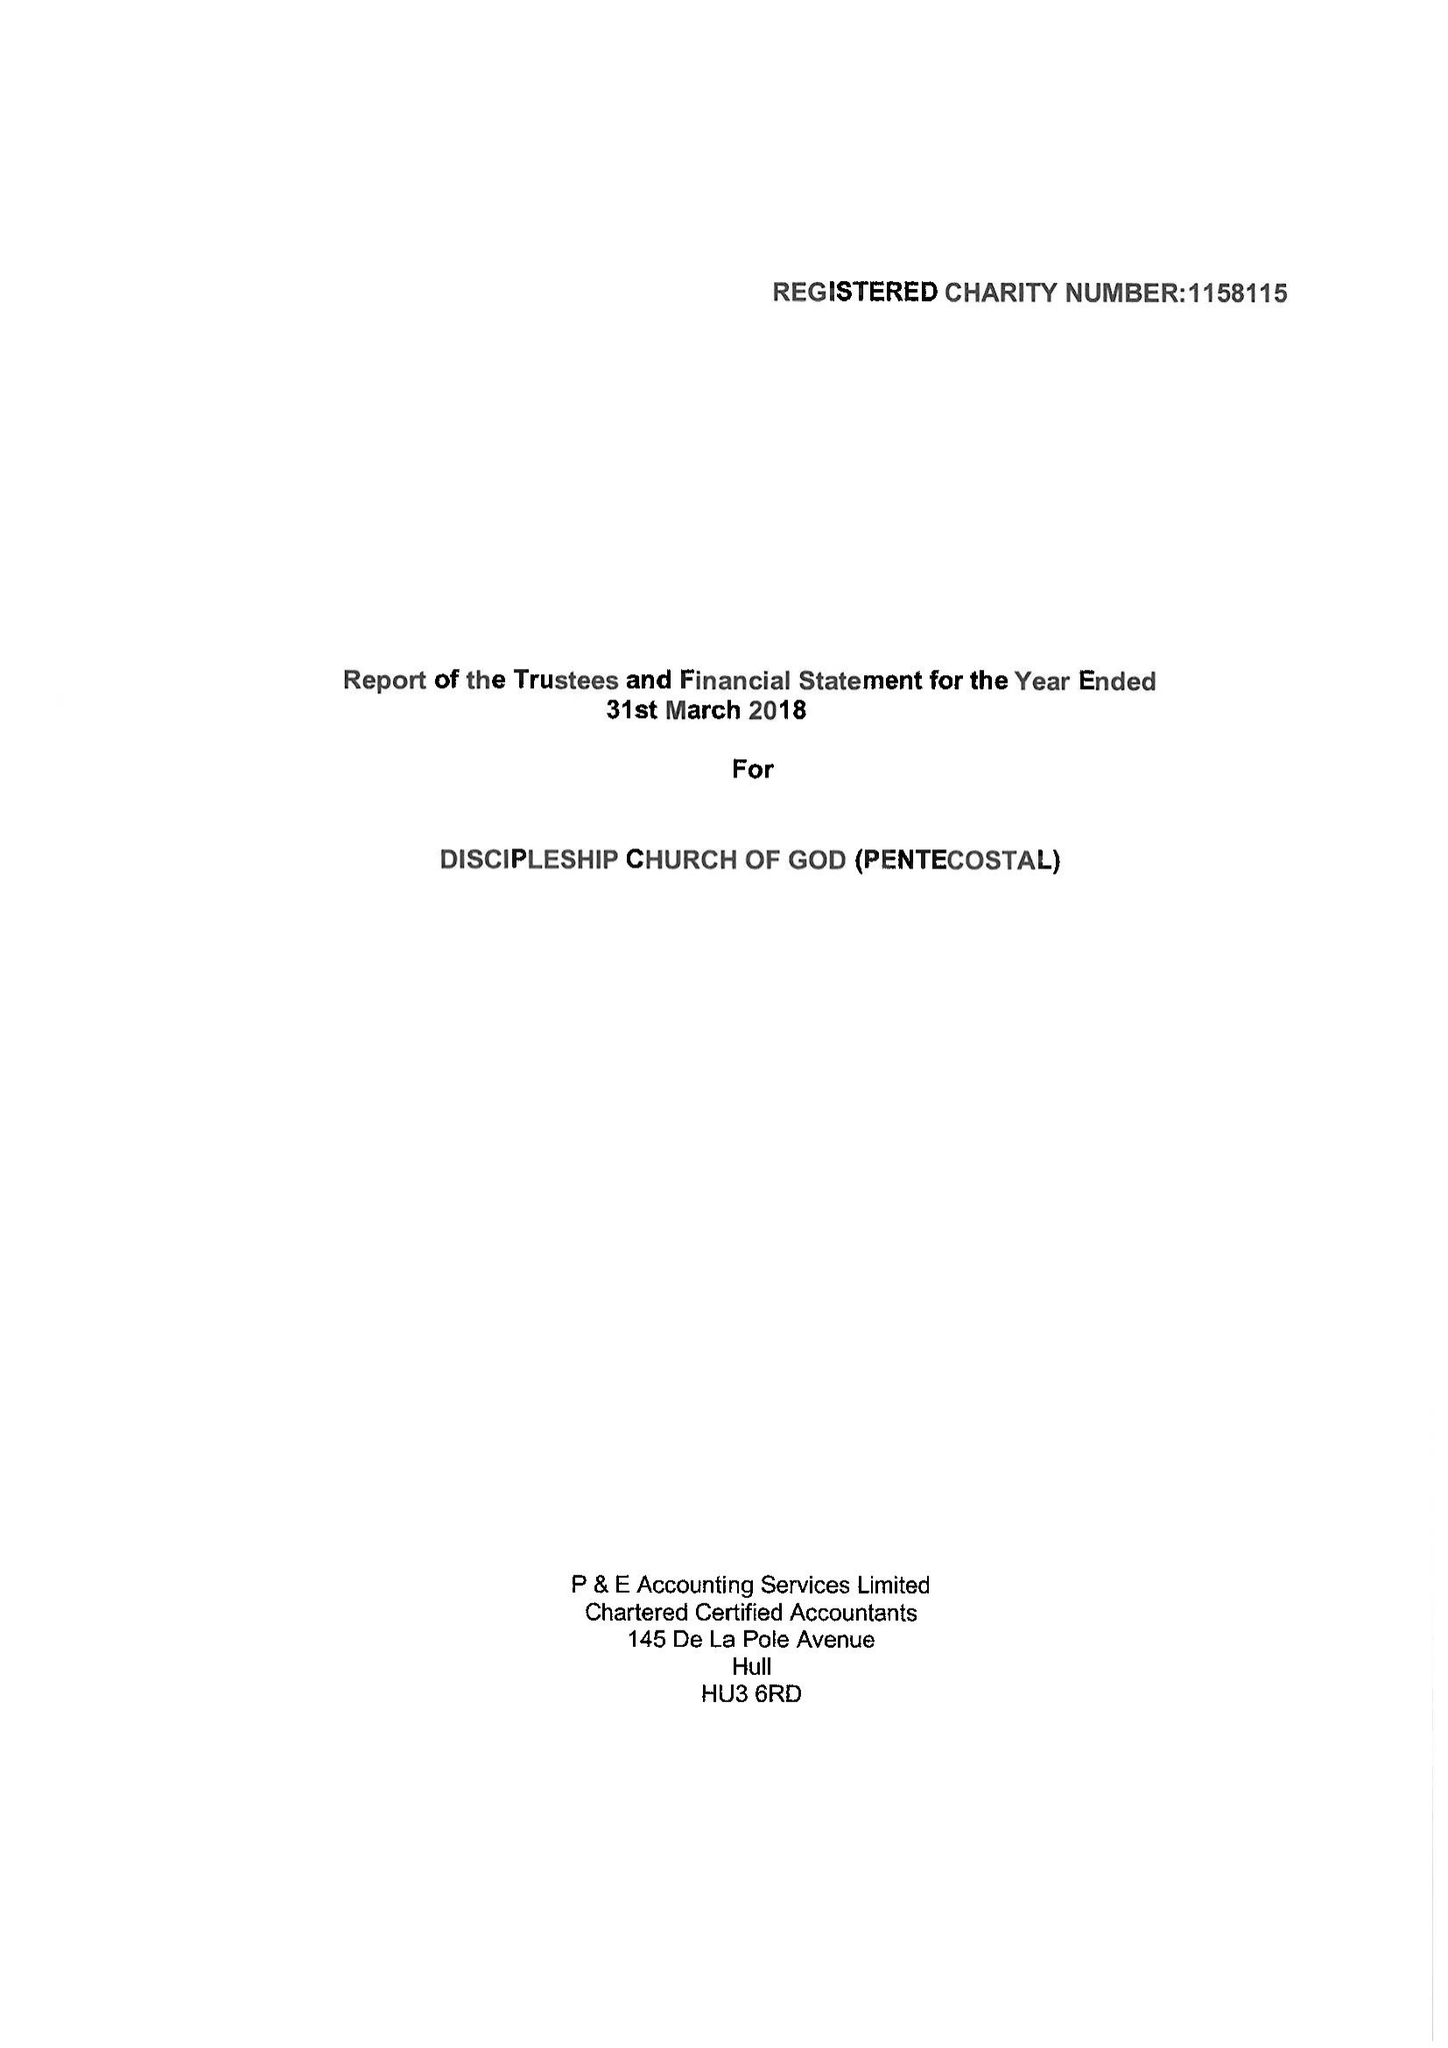What is the value for the address__post_town?
Answer the question using a single word or phrase. LONDON 